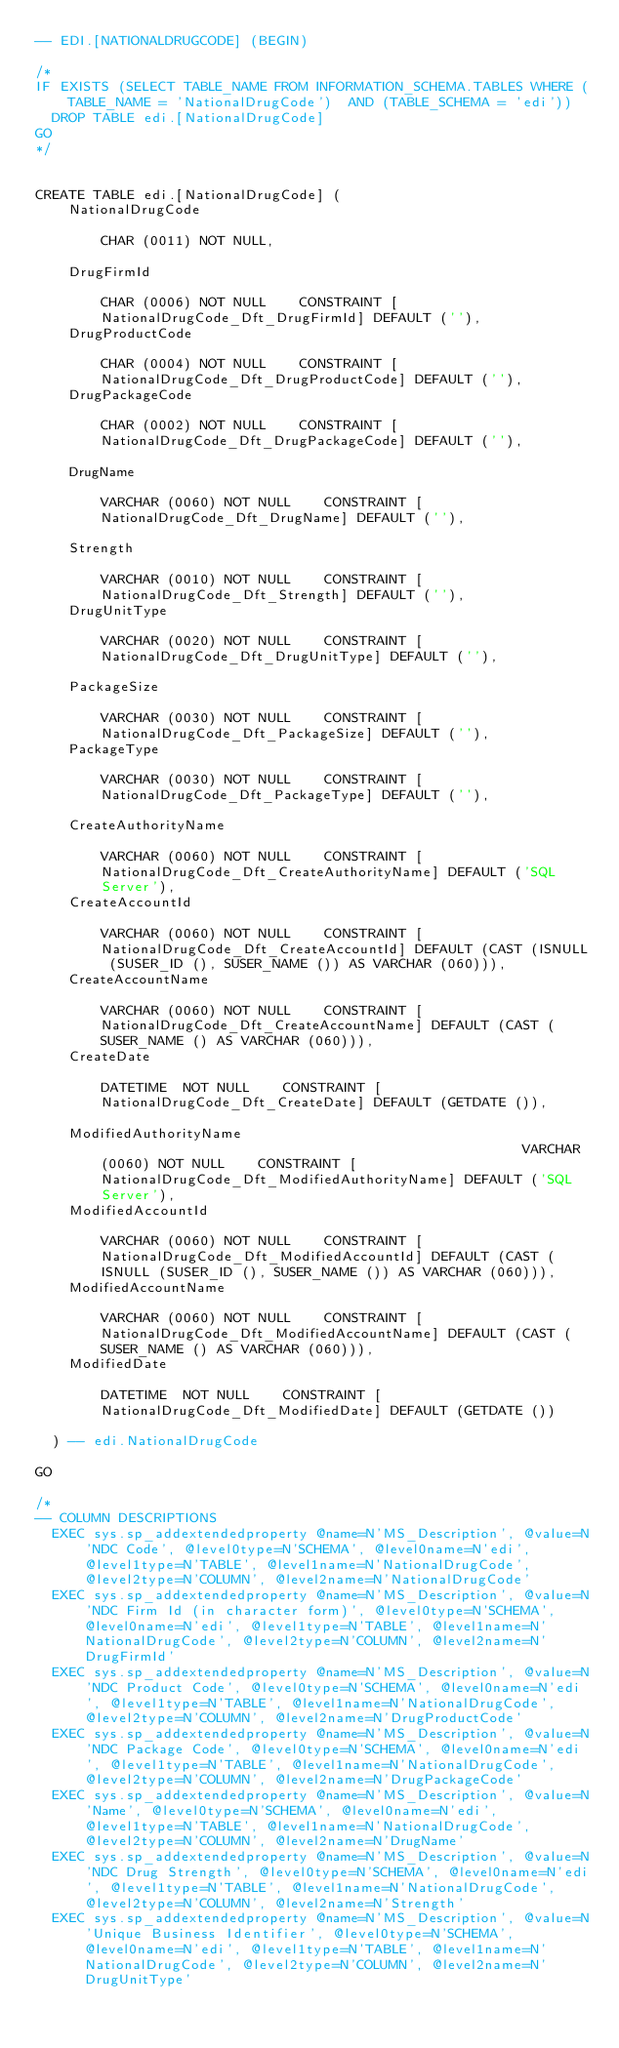<code> <loc_0><loc_0><loc_500><loc_500><_SQL_>-- EDI.[NATIONALDRUGCODE] (BEGIN) 

/* 
IF EXISTS (SELECT TABLE_NAME FROM INFORMATION_SCHEMA.TABLES WHERE (TABLE_NAME = 'NationalDrugCode')  AND (TABLE_SCHEMA = 'edi'))
  DROP TABLE edi.[NationalDrugCode]
GO 
*/ 


CREATE TABLE edi.[NationalDrugCode] (
    NationalDrugCode                                                            CHAR (0011) NOT NULL,

    DrugFirmId                                                                  CHAR (0006) NOT NULL    CONSTRAINT [NationalDrugCode_Dft_DrugFirmId] DEFAULT (''),
    DrugProductCode                                                             CHAR (0004) NOT NULL    CONSTRAINT [NationalDrugCode_Dft_DrugProductCode] DEFAULT (''),
    DrugPackageCode                                                             CHAR (0002) NOT NULL    CONSTRAINT [NationalDrugCode_Dft_DrugPackageCode] DEFAULT (''),

    DrugName                                                                 VARCHAR (0060) NOT NULL    CONSTRAINT [NationalDrugCode_Dft_DrugName] DEFAULT (''),

    Strength                                                                 VARCHAR (0010) NOT NULL    CONSTRAINT [NationalDrugCode_Dft_Strength] DEFAULT (''),
    DrugUnitType                                                             VARCHAR (0020) NOT NULL    CONSTRAINT [NationalDrugCode_Dft_DrugUnitType] DEFAULT (''),

    PackageSize                                                              VARCHAR (0030) NOT NULL    CONSTRAINT [NationalDrugCode_Dft_PackageSize] DEFAULT (''),
    PackageType                                                              VARCHAR (0030) NOT NULL    CONSTRAINT [NationalDrugCode_Dft_PackageType] DEFAULT (''),

    CreateAuthorityName                                                      VARCHAR (0060) NOT NULL    CONSTRAINT [NationalDrugCode_Dft_CreateAuthorityName] DEFAULT ('SQL Server'),
    CreateAccountId                                                          VARCHAR (0060) NOT NULL    CONSTRAINT [NationalDrugCode_Dft_CreateAccountId] DEFAULT (CAST (ISNULL (SUSER_ID (), SUSER_NAME ()) AS VARCHAR (060))),
    CreateAccountName                                                        VARCHAR (0060) NOT NULL    CONSTRAINT [NationalDrugCode_Dft_CreateAccountName] DEFAULT (CAST (SUSER_NAME () AS VARCHAR (060))),
    CreateDate                                                              DATETIME  NOT NULL    CONSTRAINT [NationalDrugCode_Dft_CreateDate] DEFAULT (GETDATE ()),

    ModifiedAuthorityName                                                    VARCHAR (0060) NOT NULL    CONSTRAINT [NationalDrugCode_Dft_ModifiedAuthorityName] DEFAULT ('SQL Server'),
    ModifiedAccountId                                                        VARCHAR (0060) NOT NULL    CONSTRAINT [NationalDrugCode_Dft_ModifiedAccountId] DEFAULT (CAST (ISNULL (SUSER_ID (), SUSER_NAME ()) AS VARCHAR (060))),
    ModifiedAccountName                                                      VARCHAR (0060) NOT NULL    CONSTRAINT [NationalDrugCode_Dft_ModifiedAccountName] DEFAULT (CAST (SUSER_NAME () AS VARCHAR (060))),
    ModifiedDate                                                            DATETIME  NOT NULL    CONSTRAINT [NationalDrugCode_Dft_ModifiedDate] DEFAULT (GETDATE ())

  ) -- edi.NationalDrugCode

GO

/* 
-- COLUMN DESCRIPTIONS 
  EXEC sys.sp_addextendedproperty @name=N'MS_Description', @value=N'NDC Code', @level0type=N'SCHEMA', @level0name=N'edi', @level1type=N'TABLE', @level1name=N'NationalDrugCode', @level2type=N'COLUMN', @level2name=N'NationalDrugCode'
  EXEC sys.sp_addextendedproperty @name=N'MS_Description', @value=N'NDC Firm Id (in character form)', @level0type=N'SCHEMA', @level0name=N'edi', @level1type=N'TABLE', @level1name=N'NationalDrugCode', @level2type=N'COLUMN', @level2name=N'DrugFirmId'
  EXEC sys.sp_addextendedproperty @name=N'MS_Description', @value=N'NDC Product Code', @level0type=N'SCHEMA', @level0name=N'edi', @level1type=N'TABLE', @level1name=N'NationalDrugCode', @level2type=N'COLUMN', @level2name=N'DrugProductCode'
  EXEC sys.sp_addextendedproperty @name=N'MS_Description', @value=N'NDC Package Code', @level0type=N'SCHEMA', @level0name=N'edi', @level1type=N'TABLE', @level1name=N'NationalDrugCode', @level2type=N'COLUMN', @level2name=N'DrugPackageCode'
  EXEC sys.sp_addextendedproperty @name=N'MS_Description', @value=N'Name', @level0type=N'SCHEMA', @level0name=N'edi', @level1type=N'TABLE', @level1name=N'NationalDrugCode', @level2type=N'COLUMN', @level2name=N'DrugName'
  EXEC sys.sp_addextendedproperty @name=N'MS_Description', @value=N'NDC Drug Strength', @level0type=N'SCHEMA', @level0name=N'edi', @level1type=N'TABLE', @level1name=N'NationalDrugCode', @level2type=N'COLUMN', @level2name=N'Strength'
  EXEC sys.sp_addextendedproperty @name=N'MS_Description', @value=N'Unique Business Identifier', @level0type=N'SCHEMA', @level0name=N'edi', @level1type=N'TABLE', @level1name=N'NationalDrugCode', @level2type=N'COLUMN', @level2name=N'DrugUnitType'</code> 